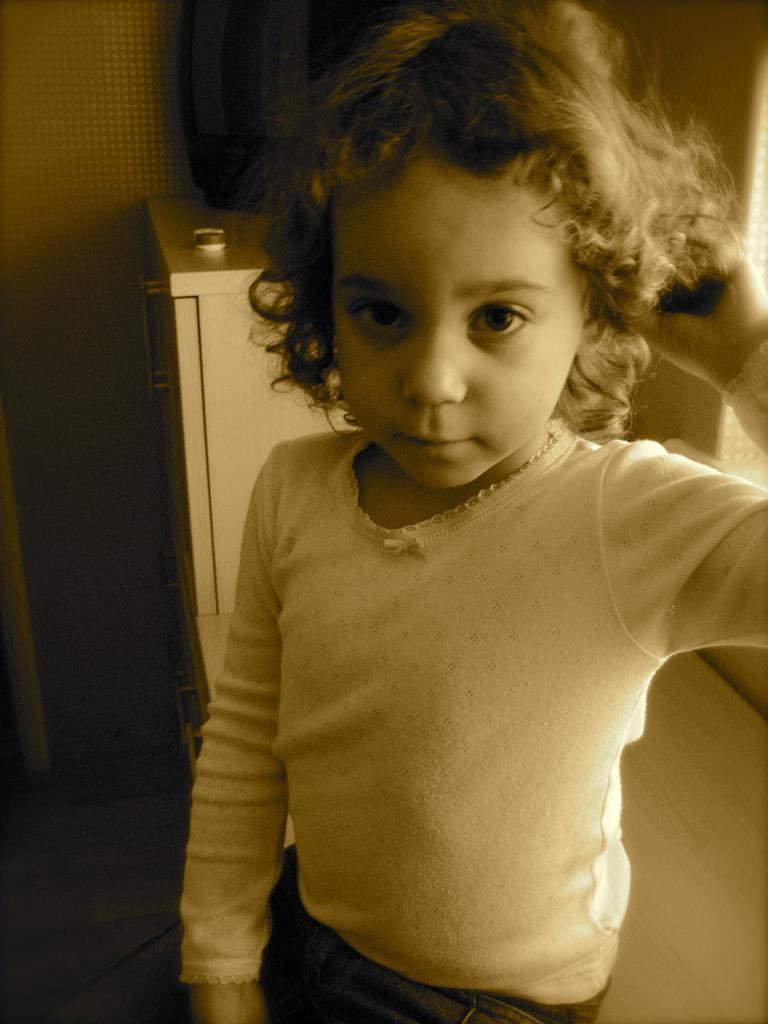Who is the main subject in the picture? There is a girl in the picture. What can be seen in the background of the picture? There are objects in the background of the picture. What is the girl's income in the picture? There is no information about the girl's income in the picture. 